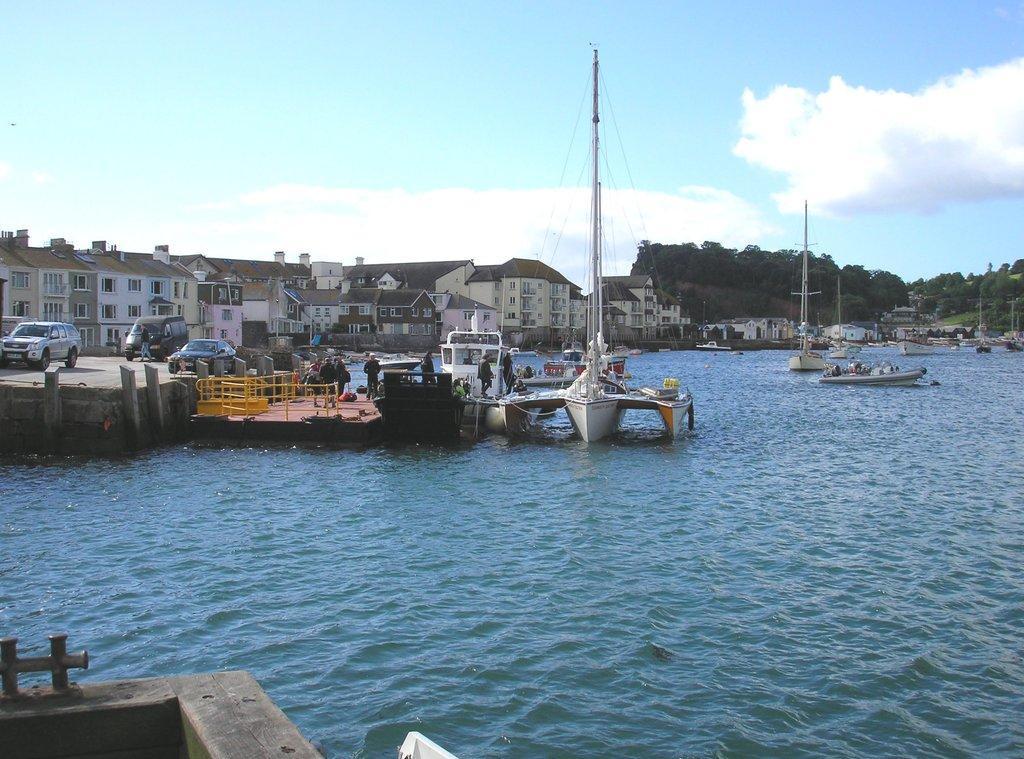Could you give a brief overview of what you see in this image? In the image there are boats in the sea and on the left side there are few cars on the land with few persons standing in the front and in the back there are buildings all over the place with trees on the left side and right side and above its sky with clouds. 